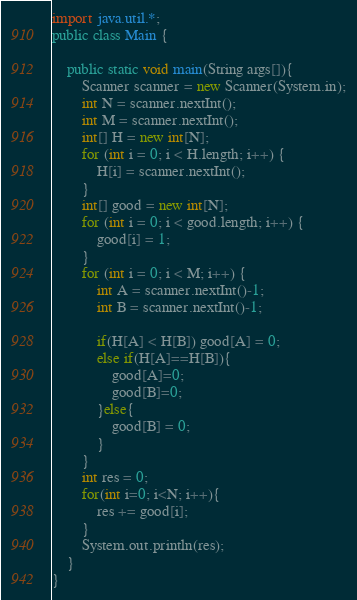Convert code to text. <code><loc_0><loc_0><loc_500><loc_500><_Java_>import java.util.*;
public class Main {
    
    public static void main(String args[]){
        Scanner scanner = new Scanner(System.in);
        int N = scanner.nextInt();
        int M = scanner.nextInt();
        int[] H = new int[N];
        for (int i = 0; i < H.length; i++) {
            H[i] = scanner.nextInt();
        }
        int[] good = new int[N];
        for (int i = 0; i < good.length; i++) {
            good[i] = 1;
        }
        for (int i = 0; i < M; i++) {
            int A = scanner.nextInt()-1;
            int B = scanner.nextInt()-1;

            if(H[A] < H[B]) good[A] = 0;
            else if(H[A]==H[B]){
                good[A]=0;
                good[B]=0;
            }else{
                good[B] = 0;
            }
        }
        int res = 0;
        for(int i=0; i<N; i++){
            res += good[i];
        }
        System.out.println(res);
    }
}</code> 